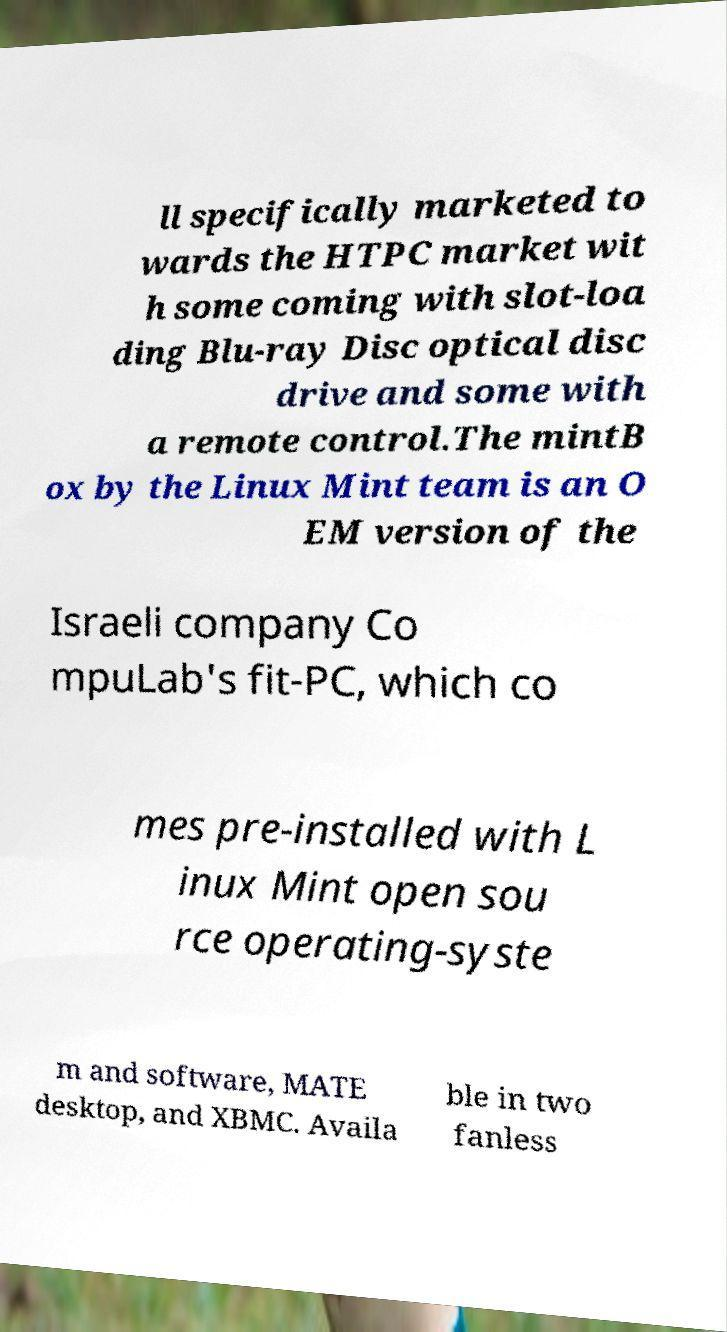Could you extract and type out the text from this image? ll specifically marketed to wards the HTPC market wit h some coming with slot-loa ding Blu-ray Disc optical disc drive and some with a remote control.The mintB ox by the Linux Mint team is an O EM version of the Israeli company Co mpuLab's fit-PC, which co mes pre-installed with L inux Mint open sou rce operating-syste m and software, MATE desktop, and XBMC. Availa ble in two fanless 